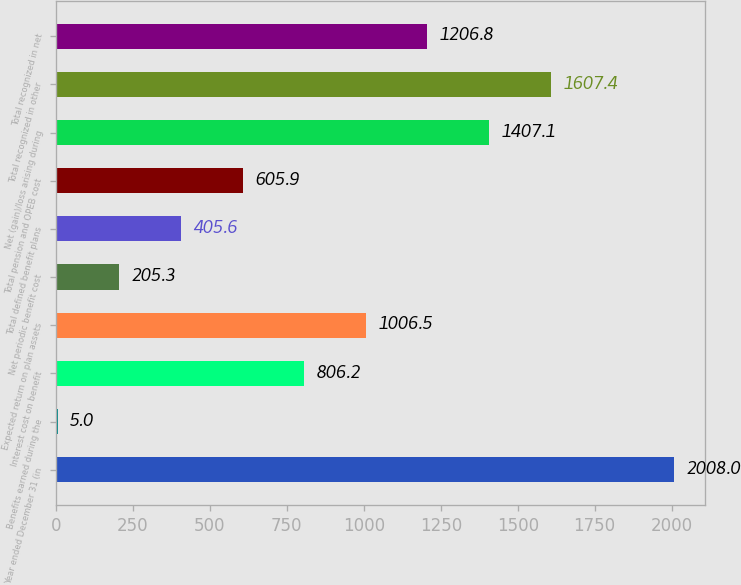Convert chart to OTSL. <chart><loc_0><loc_0><loc_500><loc_500><bar_chart><fcel>Year ended December 31 (in<fcel>Benefits earned during the<fcel>Interest cost on benefit<fcel>Expected return on plan assets<fcel>Net periodic benefit cost<fcel>Total defined benefit plans<fcel>Total pension and OPEB cost<fcel>Net (gain)/loss arising during<fcel>Total recognized in other<fcel>Total recognized in net<nl><fcel>2008<fcel>5<fcel>806.2<fcel>1006.5<fcel>205.3<fcel>405.6<fcel>605.9<fcel>1407.1<fcel>1607.4<fcel>1206.8<nl></chart> 